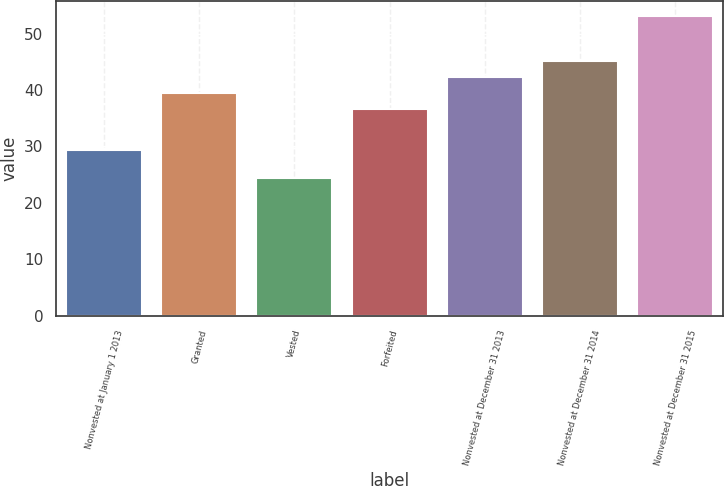Convert chart. <chart><loc_0><loc_0><loc_500><loc_500><bar_chart><fcel>Nonvested at January 1 2013<fcel>Granted<fcel>Vested<fcel>Forfeited<fcel>Nonvested at December 31 2013<fcel>Nonvested at December 31 2014<fcel>Nonvested at December 31 2015<nl><fcel>29.39<fcel>39.47<fcel>24.36<fcel>36.59<fcel>42.35<fcel>45.23<fcel>53.18<nl></chart> 